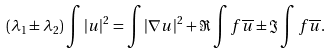<formula> <loc_0><loc_0><loc_500><loc_500>( \lambda _ { 1 } \pm \lambda _ { 2 } ) \int | u | ^ { 2 } = \int | \nabla u | ^ { 2 } + \Re \int f \overline { u } \pm \Im \int f \overline { u } .</formula> 